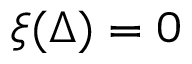<formula> <loc_0><loc_0><loc_500><loc_500>\xi ( \Delta ) = 0</formula> 